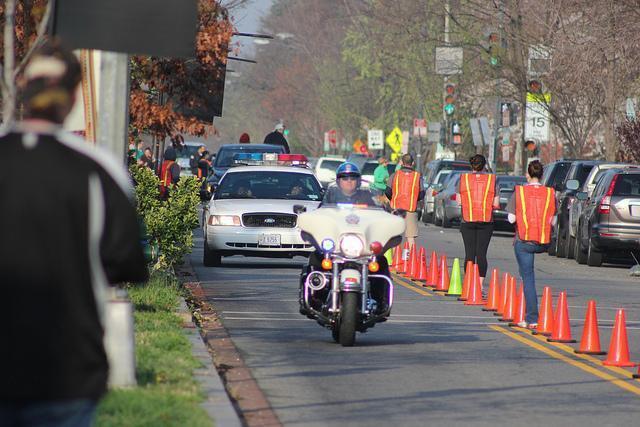How many motorcycles are in the crosswalk?
Give a very brief answer. 1. How many people are there?
Give a very brief answer. 4. How many cars are visible?
Give a very brief answer. 2. 